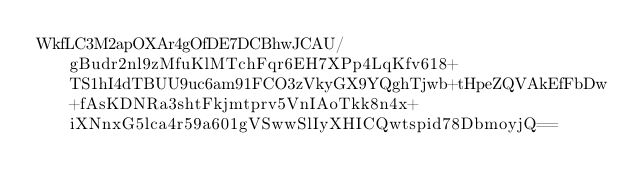<code> <loc_0><loc_0><loc_500><loc_500><_SML_>WkfLC3M2apOXAr4gOfDE7DCBhwJCAU/gBudr2nl9zMfuKlMTchFqr6EH7XPp4LqKfv618+TS1hI4dTBUU9uc6am91FCO3zVkyGX9YQghTjwb+tHpeZQVAkEfFbDw+fAsKDNRa3shtFkjmtprv5VnIAoTkk8n4x+iXNnxG5lca4r59a601gVSwwSlIyXHICQwtspid78DbmoyjQ==</code> 